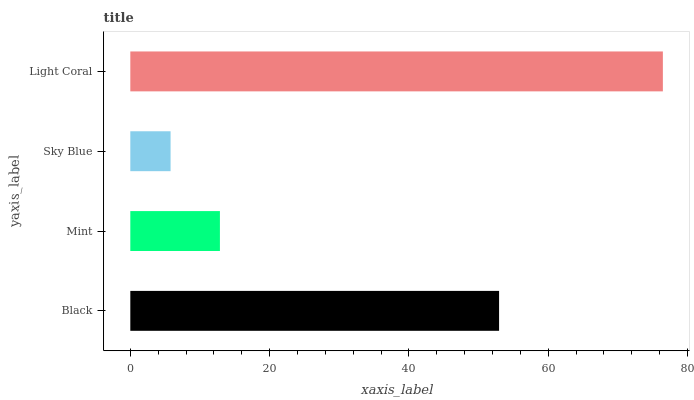Is Sky Blue the minimum?
Answer yes or no. Yes. Is Light Coral the maximum?
Answer yes or no. Yes. Is Mint the minimum?
Answer yes or no. No. Is Mint the maximum?
Answer yes or no. No. Is Black greater than Mint?
Answer yes or no. Yes. Is Mint less than Black?
Answer yes or no. Yes. Is Mint greater than Black?
Answer yes or no. No. Is Black less than Mint?
Answer yes or no. No. Is Black the high median?
Answer yes or no. Yes. Is Mint the low median?
Answer yes or no. Yes. Is Mint the high median?
Answer yes or no. No. Is Sky Blue the low median?
Answer yes or no. No. 